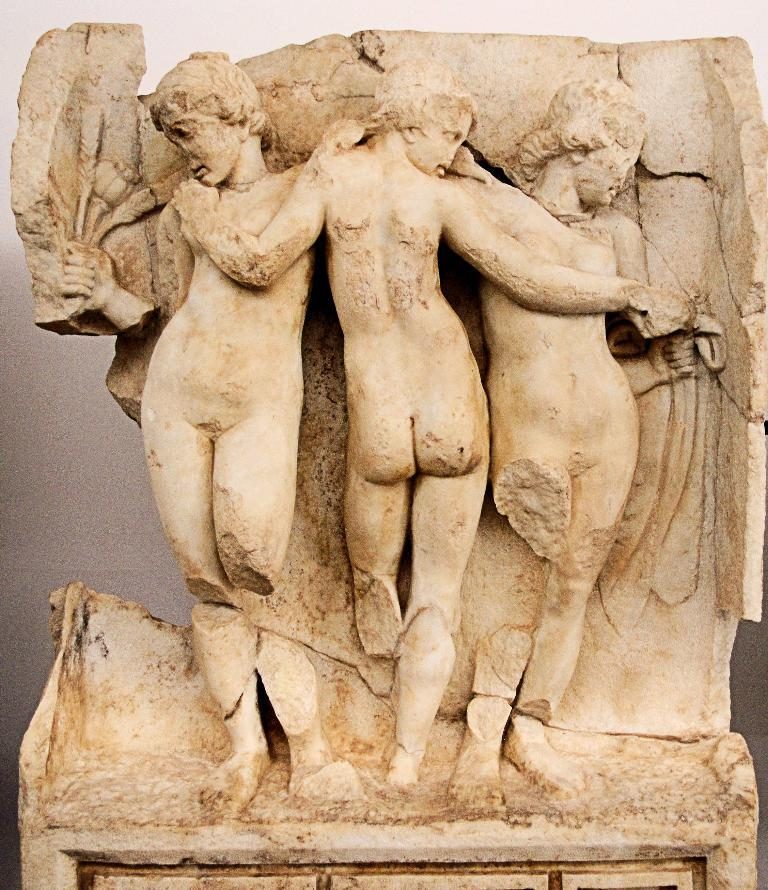What is the main subject of the image? There is a sculpture in the image. What is the sculpture resting on? The sculpture is on a stone. What can be seen in the background of the image? There is a wall in the background of the image. What color is the wall? The wall is painted white. Can you give an example of a bed that can be seen in the image? There is no bed present in the image; it features a sculpture on a stone with a white wall in the background. 